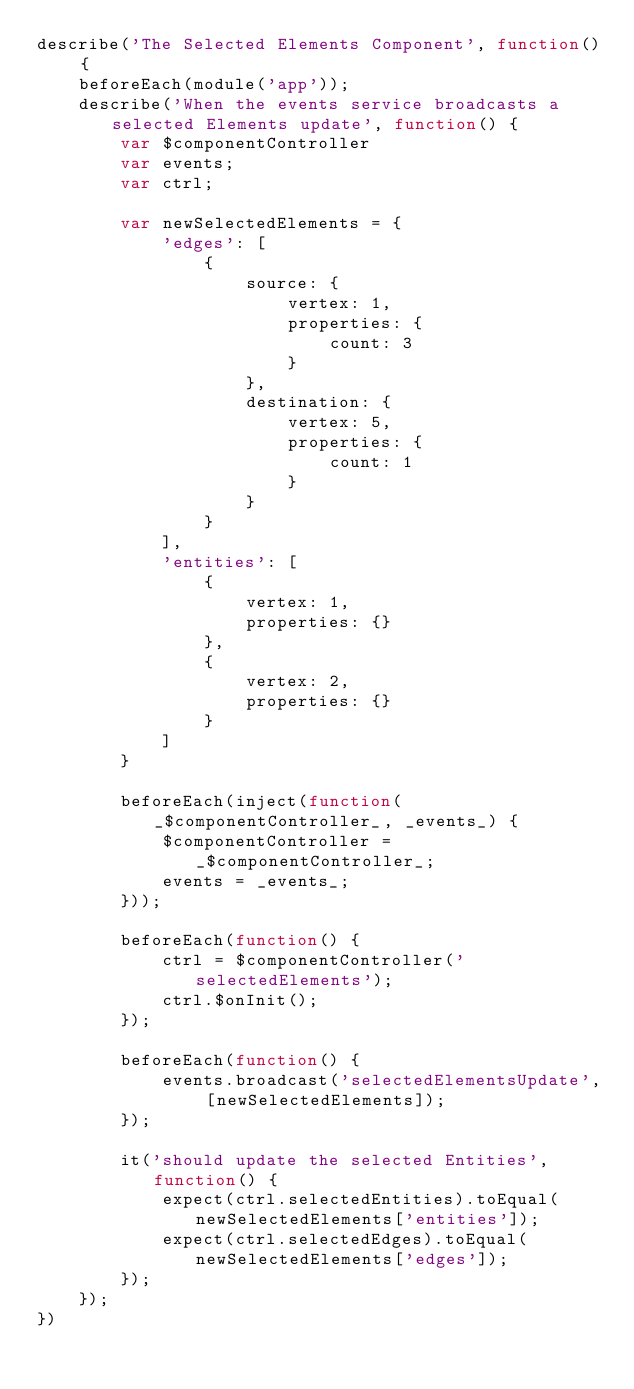<code> <loc_0><loc_0><loc_500><loc_500><_JavaScript_>describe('The Selected Elements Component', function() {
    beforeEach(module('app'));
    describe('When the events service broadcasts a selected Elements update', function() {
        var $componentController
        var events;
        var ctrl;

        var newSelectedElements = {
            'edges': [
                {
                    source: {
                        vertex: 1,
                        properties: {
                            count: 3
                        }
                    },
                    destination: {
                        vertex: 5,
                        properties: {
                            count: 1
                        }
                    }
                }
            ],
            'entities': [
                {
                    vertex: 1,
                    properties: {}
                },
                {
                    vertex: 2,
                    properties: {}
                }
            ]
        }

        beforeEach(inject(function(_$componentController_, _events_) {
            $componentController = _$componentController_;
            events = _events_;
        }));

        beforeEach(function() {
            ctrl = $componentController('selectedElements');
            ctrl.$onInit();
        });

        beforeEach(function() {
            events.broadcast('selectedElementsUpdate', [newSelectedElements]);
        });

        it('should update the selected Entities', function() {
            expect(ctrl.selectedEntities).toEqual(newSelectedElements['entities']);
            expect(ctrl.selectedEdges).toEqual(newSelectedElements['edges']);
        });
    });
})
</code> 